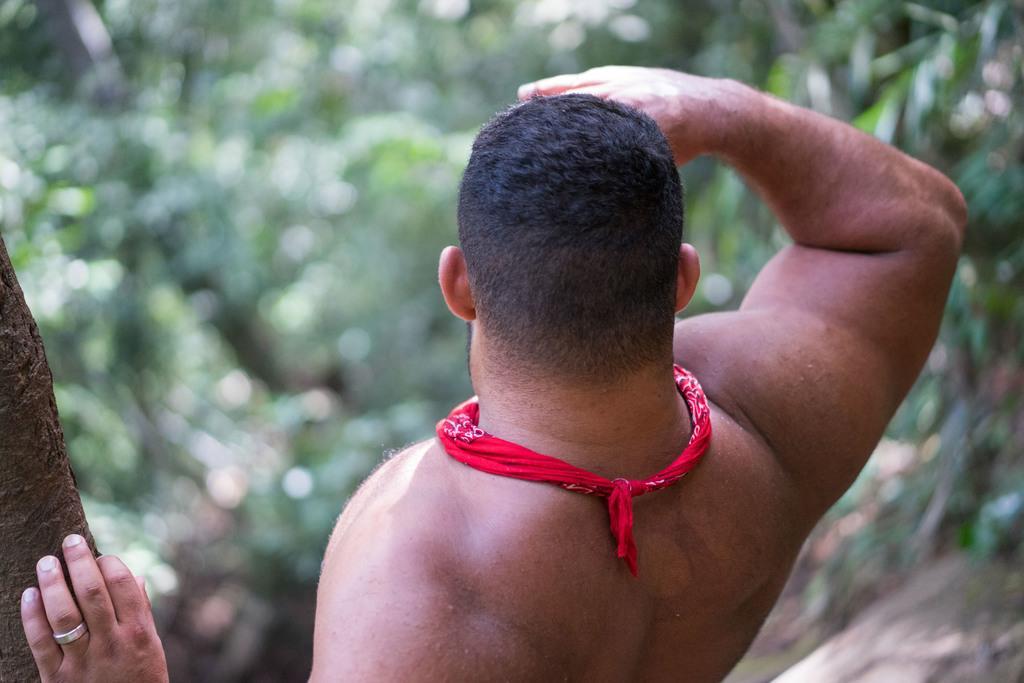Describe this image in one or two sentences. In this image there is a man standing beside the tree trunk in front of him there are so many trees. 